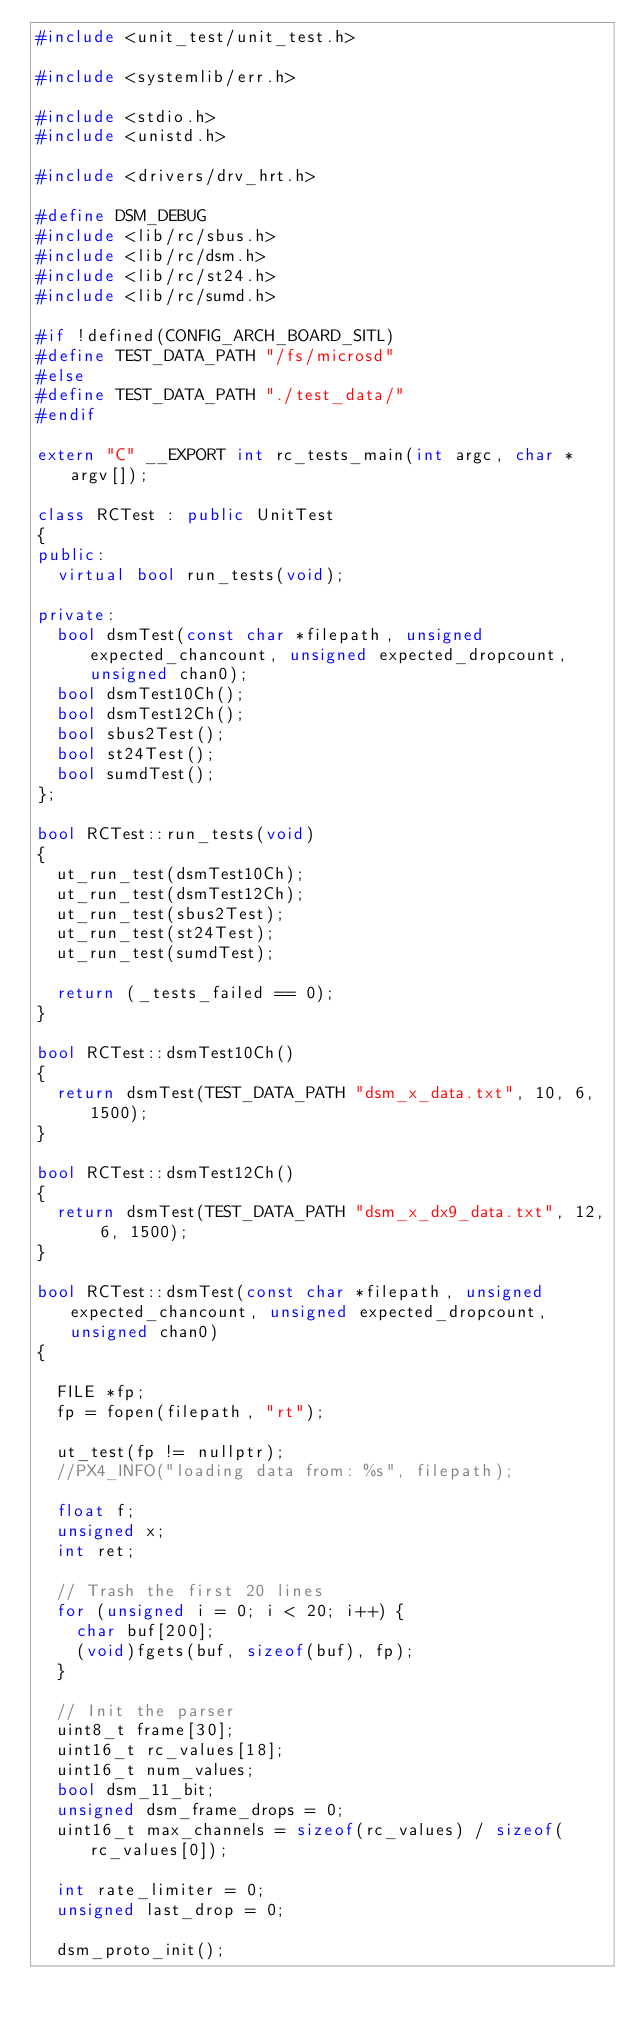Convert code to text. <code><loc_0><loc_0><loc_500><loc_500><_C++_>#include <unit_test/unit_test.h>

#include <systemlib/err.h>

#include <stdio.h>
#include <unistd.h>

#include <drivers/drv_hrt.h>

#define DSM_DEBUG
#include <lib/rc/sbus.h>
#include <lib/rc/dsm.h>
#include <lib/rc/st24.h>
#include <lib/rc/sumd.h>

#if !defined(CONFIG_ARCH_BOARD_SITL)
#define TEST_DATA_PATH "/fs/microsd"
#else
#define TEST_DATA_PATH "./test_data/"
#endif

extern "C" __EXPORT int rc_tests_main(int argc, char *argv[]);

class RCTest : public UnitTest
{
public:
	virtual bool run_tests(void);

private:
	bool dsmTest(const char *filepath, unsigned expected_chancount, unsigned expected_dropcount, unsigned chan0);
	bool dsmTest10Ch();
	bool dsmTest12Ch();
	bool sbus2Test();
	bool st24Test();
	bool sumdTest();
};

bool RCTest::run_tests(void)
{
	ut_run_test(dsmTest10Ch);
	ut_run_test(dsmTest12Ch);
	ut_run_test(sbus2Test);
	ut_run_test(st24Test);
	ut_run_test(sumdTest);

	return (_tests_failed == 0);
}

bool RCTest::dsmTest10Ch()
{
	return dsmTest(TEST_DATA_PATH "dsm_x_data.txt", 10, 6, 1500);
}

bool RCTest::dsmTest12Ch()
{
	return dsmTest(TEST_DATA_PATH "dsm_x_dx9_data.txt", 12, 6, 1500);
}

bool RCTest::dsmTest(const char *filepath, unsigned expected_chancount, unsigned expected_dropcount, unsigned chan0)
{

	FILE *fp;
	fp = fopen(filepath, "rt");

	ut_test(fp != nullptr);
	//PX4_INFO("loading data from: %s", filepath);

	float f;
	unsigned x;
	int ret;

	// Trash the first 20 lines
	for (unsigned i = 0; i < 20; i++) {
		char buf[200];
		(void)fgets(buf, sizeof(buf), fp);
	}

	// Init the parser
	uint8_t frame[30];
	uint16_t rc_values[18];
	uint16_t num_values;
	bool dsm_11_bit;
	unsigned dsm_frame_drops = 0;
	uint16_t max_channels = sizeof(rc_values) / sizeof(rc_values[0]);

	int rate_limiter = 0;
	unsigned last_drop = 0;

	dsm_proto_init();
</code> 